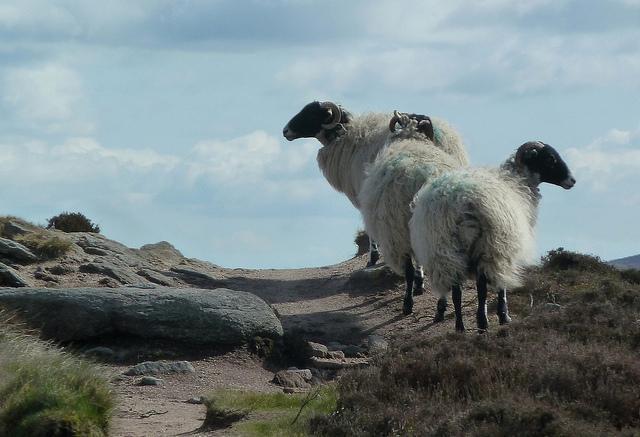What is a process that is related to these animals?
Indicate the correct choice and explain in the format: 'Answer: answer
Rationale: rationale.'
Options: Nuclear fusion, shearing, soaring, photosynthesis. Answer: shearing.
Rationale: Sheep get sheared for their wool when it gets very long. 